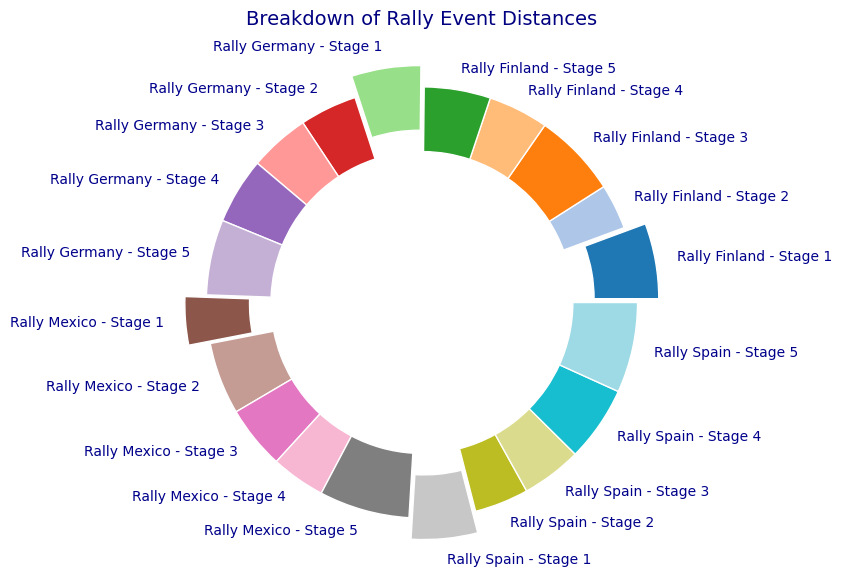what percentage of the total distance does Rally Mexico cover? From the pie chart, sum up the individual percentages for each stage of Rally Mexico. Add up 16+24+21+18+30 to get 109. To get the overall percentage, you have to divide by the total distance of all events combined and multiply by 100. But this is visualized in the chart directly.
Answer: 15.4% Which rally event has the shortest distance among all stages? Look at the segment in the pie chart with the smallest percentage. The smallest wedge in the pie chart would indicate the smallest segment.
Answer: Rally Finland - Stage 2 How does the distance of Stage 4 in Rally Spain compare to Stage 4 in Rally Mexico? Visually compare the segments labeled Rally Spain - Stage 4 and Rally Mexico - Stage 4 in the pie chart. Determine which segment is larger to compare the distances.
Answer: Stage 4 in Rally Spain is greater What is the total distance covered by the last stages of all rally events combined? Identify and sum the individual wedges labeled as Stage 5 for all rallies. Specifically, add 30 (Spain) + 22 (Finland) + 30 (Mexico) + 25 (Germany) = 107 km.
Answer: 107 km Which category (stage) has the highest percentage in Rally Germany? Visually check the wedges of Rally Germany and look for the one with the largest area. Since each category from Stage 1 to Stage 5 will have a distinct segment, the largest should be easily observed.
Answer: Stage 5 Compare the total distance covered in Rally Spain to Rally Finland. Visually compare the sum of the distances (wedges) for all stages in Rally Spain and Rally Finland. Each rally’s total distance can be derived by summing up their respective segments.
Answer: Rally Spain is greater Which event contributes the most to the overall pie chart? By comparing the size of the wedges associated with each event, identify which rally event (sum of all stages in that event) has the largest portion in the pie chart.
Answer: Rally Spain What's the difference in distance between Stage 3 of Rally Mexico and Stage 3 of Rally Germany? Look at the specific wedges corresponding to Stage 3 for both Rally Mexico and Rally Germany. Subtract the smaller distance from the larger distance.
Answer: 1 km What is the combined percentage of Stage 1 distances for all rally events in the pie chart? Locate and sum the percentages for each Stage 1 wedge from all rally events. Add up the individual slices representing Stage 1 across all rallies.
Answer: 13.2% How does the distance of Stage 2 in Rally Spain compare visually to the Stage 2 in Rally Finland? Visually compare the wedges for Rally Spain - Stage 2 and Rally Finland - Stage 2 within the pie chart by examining the relative sizes of the respective segments.
Answer: Rally Spain - Stage 2 is greater 